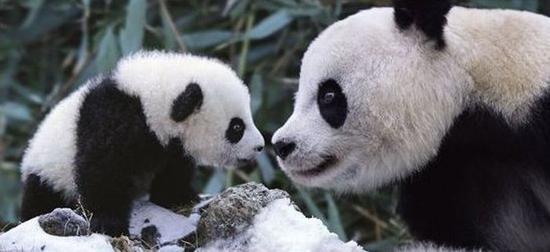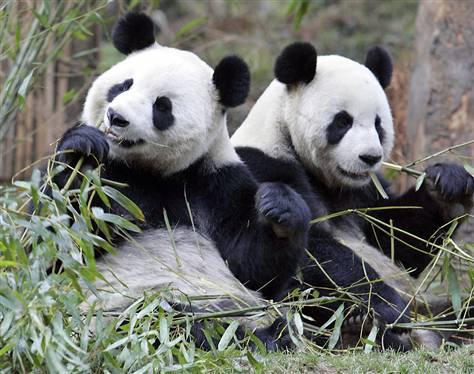The first image is the image on the left, the second image is the image on the right. Evaluate the accuracy of this statement regarding the images: "In one image, two pandas are sitting close together with at least one of them clutching a green stalk, and the other image shows two pandas with their bodies facing.". Is it true? Answer yes or no. Yes. 